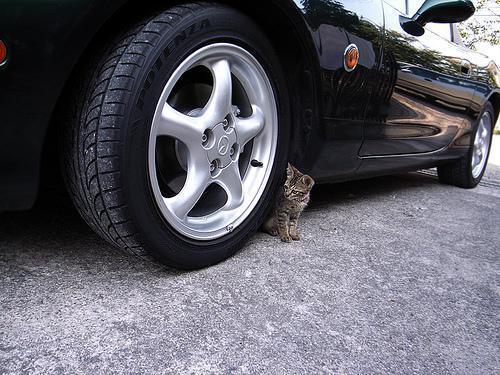How many kittens under the car?
Give a very brief answer. 1. How many cars in the photo?
Give a very brief answer. 1. How many tires are seen in the picture?
Give a very brief answer. 2. 